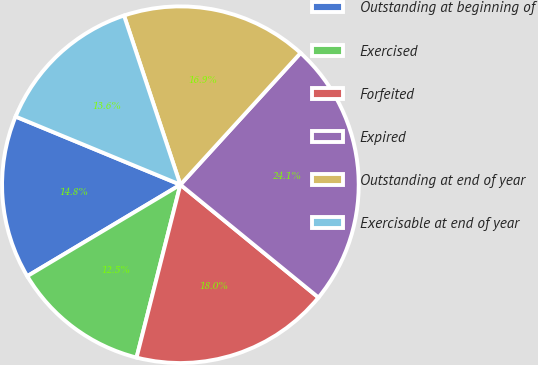Convert chart to OTSL. <chart><loc_0><loc_0><loc_500><loc_500><pie_chart><fcel>Outstanding at beginning of<fcel>Exercised<fcel>Forfeited<fcel>Expired<fcel>Outstanding at end of year<fcel>Exercisable at end of year<nl><fcel>14.81%<fcel>12.48%<fcel>18.05%<fcel>24.13%<fcel>16.89%<fcel>13.64%<nl></chart> 